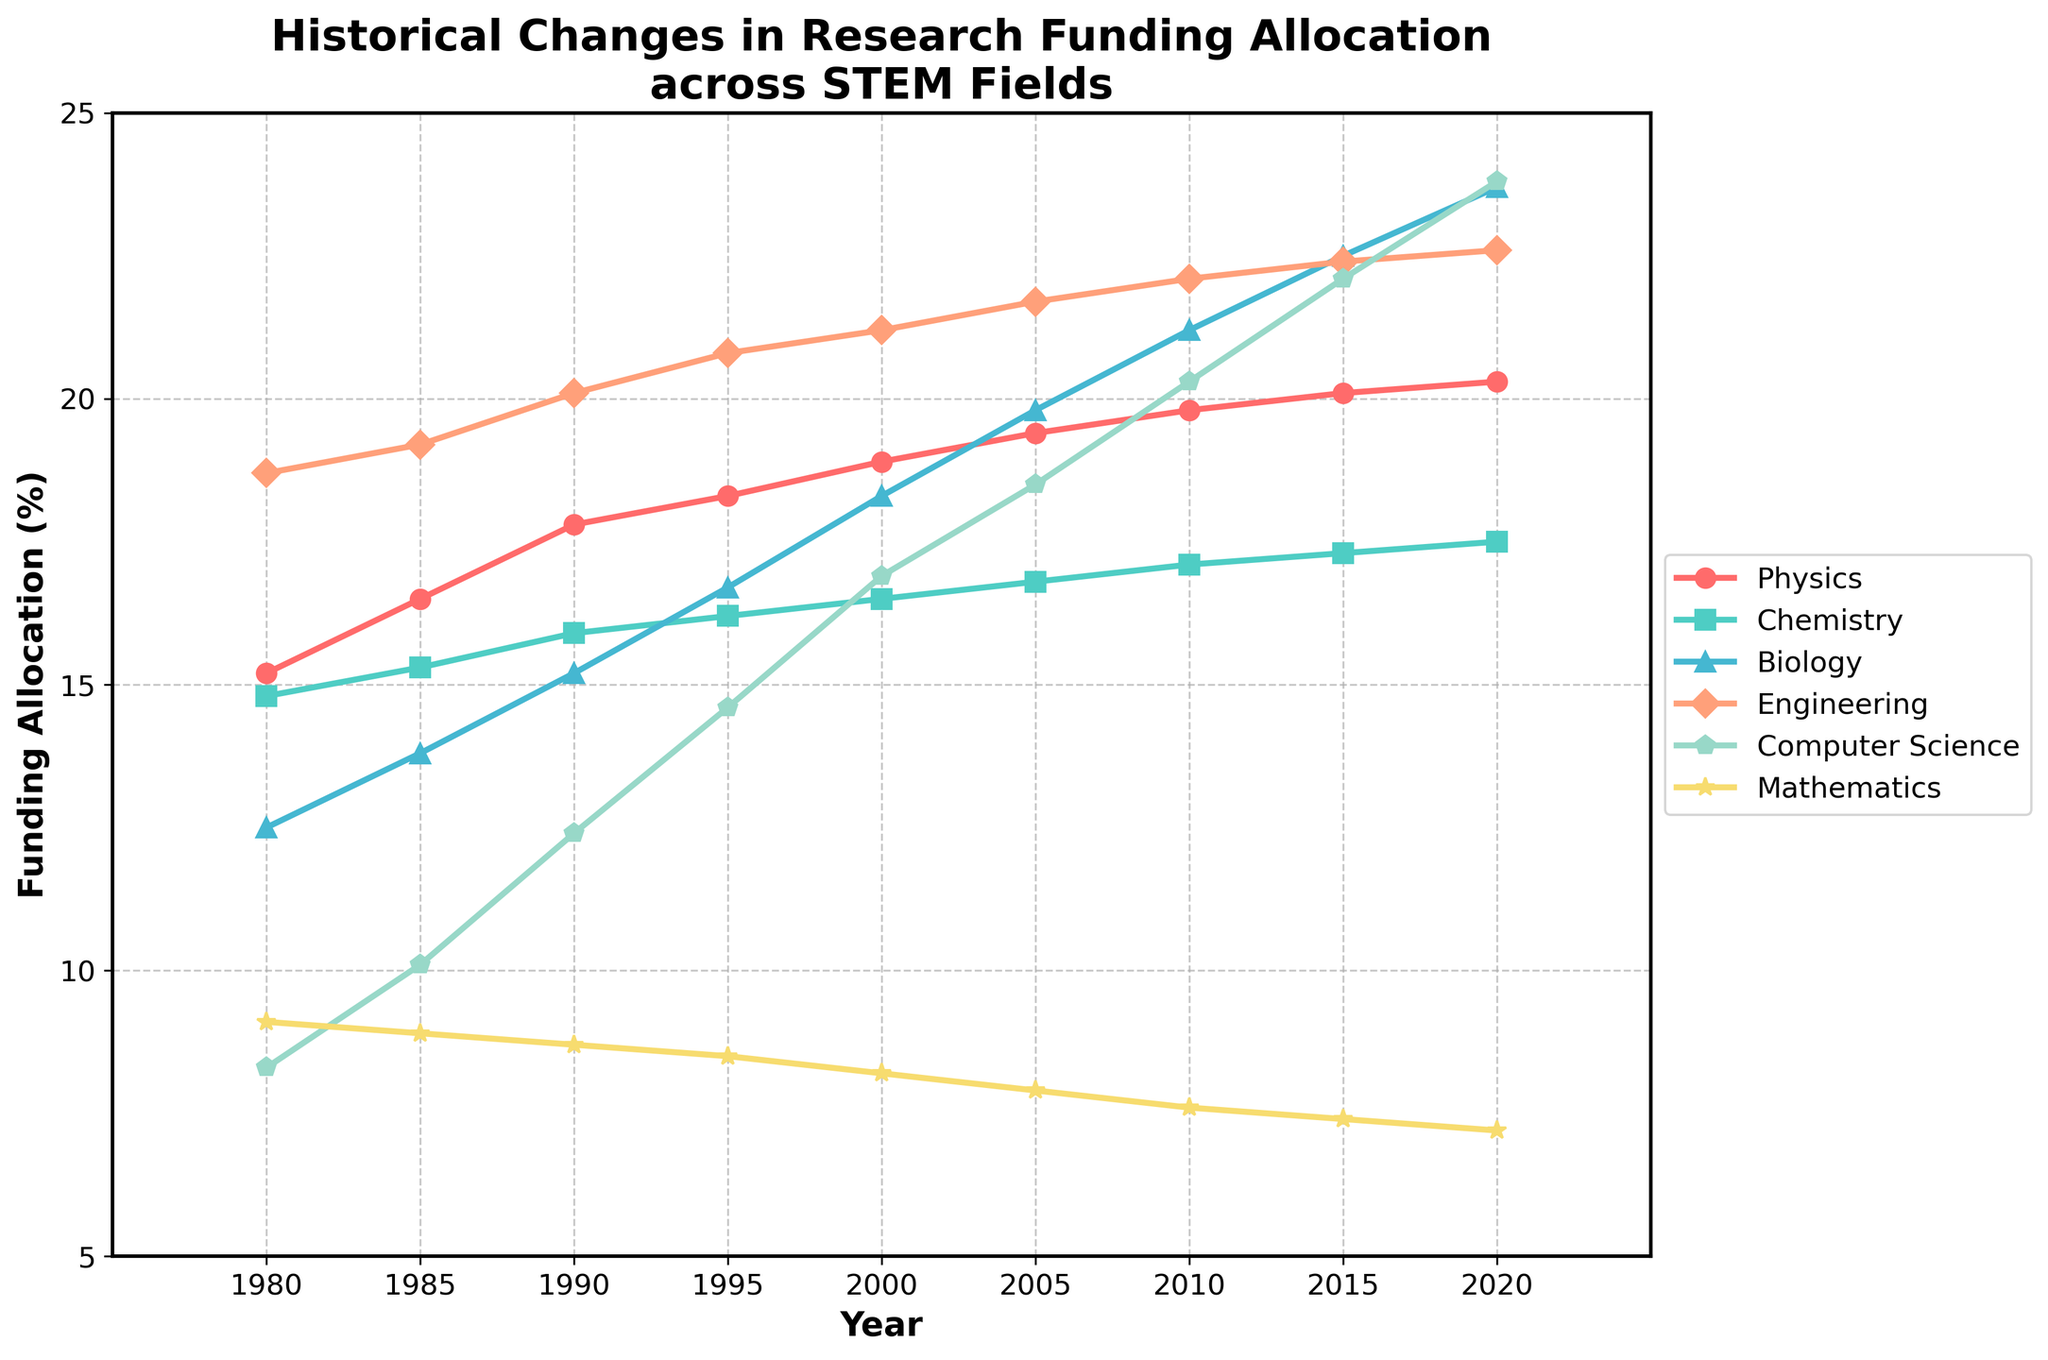What is the field with the highest funding allocation in the year 2020? Look at the graph for the year 2020 and observe the lines of different colors representing each field. The highest point in 2020 corresponds to the field with the highest funding allocation.
Answer: Computer Science In which year did Biology surpass Chemistry in funding allocation? Observe the lines representing Biology and Chemistry. Track their progression over the years and find the year where the line for Biology moves above the line for Chemistry.
Answer: 1995 By how much did the funding allocation for Computer Science increase from 1980 to 2020? Look at the points for Computer Science in the years 1980 and 2020. Subtract the percentage in 1980 from the percentage in 2020 to find the increase.
Answer: 15.5% Which field had the smallest change in funding allocation between 1980 and 2020? Calculate the difference between the funding allocations for 1980 and 2020 for each field. The field with the smallest difference has the smallest change.
Answer: Mathematics What are the three fields with the highest funding allocation in the year 2015? Look at the graph for the year 2015 and observe the positions of the lines. The top three lines represent the fields with the highest funding allocation.
Answer: Biology, Engineering, Computer Science Which field shows a consistently increasing trend from 1980 to 2020? Observe the lines for each field and identify the one that continuously rises without any significant dips.
Answer: Computer Science What is the difference in funding allocation between Physics and Mathematics in 1990? Look at the points for Physics and Mathematics in the year 1990. Subtract the percentage of Mathematics from the percentage of Physics.
Answer: 9.1% In which year did Engineering have the highest increase in funding allocation compared to the previous year? Observe the slope of the line representing Engineering and find the year with the steepest positive slope.
Answer: 1990 Which field had the lowest funding allocation in 2000, and what was the percentage? Look at the points for the year 2000 and identify the lowest point along with its corresponding value.
Answer: Mathematics, 8.2% What is the average funding allocation for Chemistry over the provided years? Sum the funding allocations for Chemistry from 1980 to 2020 and divide by the number of data points (9).
Answer: 16.2% 